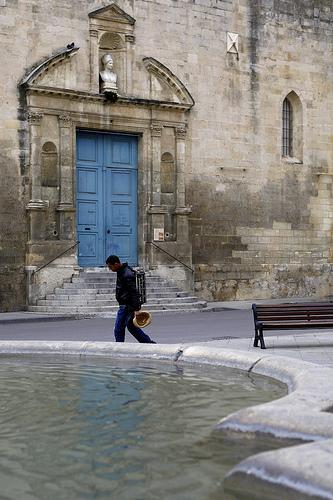Question: when was the picture taken?
Choices:
A. At night.
B. Daytime.
C. In the evening.
D. In the morning.
Answer with the letter. Answer: B Question: who is near the church?
Choices:
A. A nun.
B. A man with an accordion.
C. A preacher.
D. A police officer.
Answer with the letter. Answer: B Question: what is the man carrying on his back?
Choices:
A. An accordion.
B. A child.
C. A backpack.
D. A guitar case.
Answer with the letter. Answer: A Question: how is the man traveling?
Choices:
A. On bicycle.
B. On foot.
C. On a train.
D. On an airplane.
Answer with the letter. Answer: B 